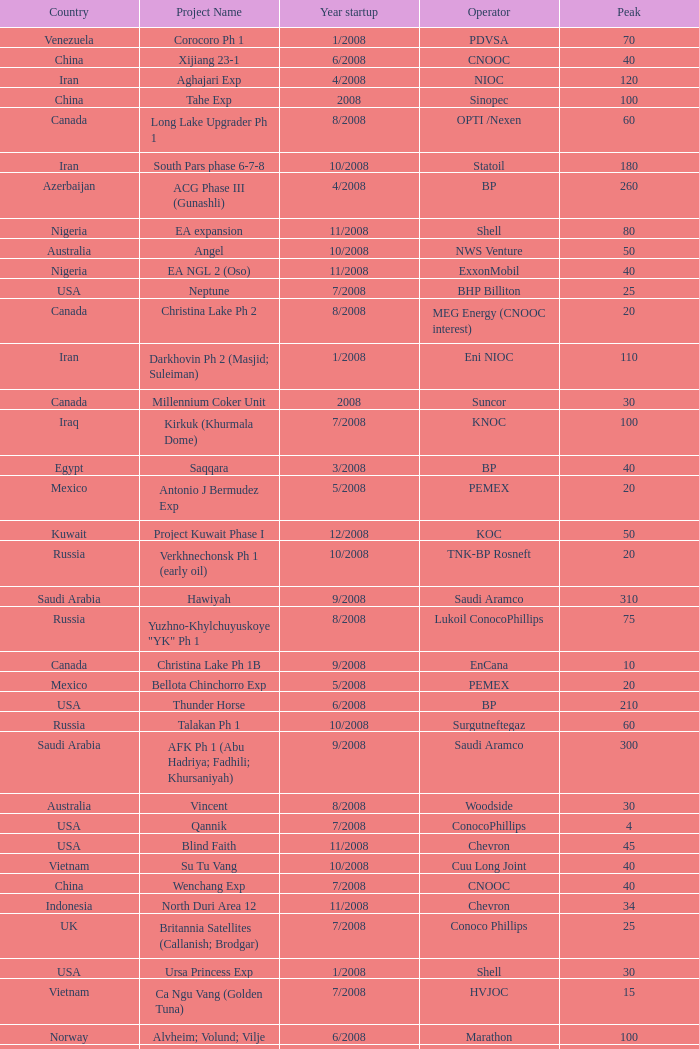Give me the full table as a dictionary. {'header': ['Country', 'Project Name', 'Year startup', 'Operator', 'Peak'], 'rows': [['Venezuela', 'Corocoro Ph 1', '1/2008', 'PDVSA', '70'], ['China', 'Xijiang 23-1', '6/2008', 'CNOOC', '40'], ['Iran', 'Aghajari Exp', '4/2008', 'NIOC', '120'], ['China', 'Tahe Exp', '2008', 'Sinopec', '100'], ['Canada', 'Long Lake Upgrader Ph 1', '8/2008', 'OPTI /Nexen', '60'], ['Iran', 'South Pars phase 6-7-8', '10/2008', 'Statoil', '180'], ['Azerbaijan', 'ACG Phase III (Gunashli)', '4/2008', 'BP', '260'], ['Nigeria', 'EA expansion', '11/2008', 'Shell', '80'], ['Australia', 'Angel', '10/2008', 'NWS Venture', '50'], ['Nigeria', 'EA NGL 2 (Oso)', '11/2008', 'ExxonMobil', '40'], ['USA', 'Neptune', '7/2008', 'BHP Billiton', '25'], ['Canada', 'Christina Lake Ph 2', '8/2008', 'MEG Energy (CNOOC interest)', '20'], ['Iran', 'Darkhovin Ph 2 (Masjid; Suleiman)', '1/2008', 'Eni NIOC', '110'], ['Canada', 'Millennium Coker Unit', '2008', 'Suncor', '30'], ['Iraq', 'Kirkuk (Khurmala Dome)', '7/2008', 'KNOC', '100'], ['Egypt', 'Saqqara', '3/2008', 'BP', '40'], ['Mexico', 'Antonio J Bermudez Exp', '5/2008', 'PEMEX', '20'], ['Kuwait', 'Project Kuwait Phase I', '12/2008', 'KOC', '50'], ['Russia', 'Verkhnechonsk Ph 1 (early oil)', '10/2008', 'TNK-BP Rosneft', '20'], ['Saudi Arabia', 'Hawiyah', '9/2008', 'Saudi Aramco', '310'], ['Russia', 'Yuzhno-Khylchuyuskoye "YK" Ph 1', '8/2008', 'Lukoil ConocoPhillips', '75'], ['Canada', 'Christina Lake Ph 1B', '9/2008', 'EnCana', '10'], ['Mexico', 'Bellota Chinchorro Exp', '5/2008', 'PEMEX', '20'], ['USA', 'Thunder Horse', '6/2008', 'BP', '210'], ['Russia', 'Talakan Ph 1', '10/2008', 'Surgutneftegaz', '60'], ['Saudi Arabia', 'AFK Ph 1 (Abu Hadriya; Fadhili; Khursaniyah)', '9/2008', 'Saudi Aramco', '300'], ['Australia', 'Vincent', '8/2008', 'Woodside', '30'], ['USA', 'Qannik', '7/2008', 'ConocoPhillips', '4'], ['USA', 'Blind Faith', '11/2008', 'Chevron', '45'], ['Vietnam', 'Su Tu Vang', '10/2008', 'Cuu Long Joint', '40'], ['China', 'Wenchang Exp', '7/2008', 'CNOOC', '40'], ['Indonesia', 'North Duri Area 12', '11/2008', 'Chevron', '34'], ['UK', 'Britannia Satellites (Callanish; Brodgar)', '7/2008', 'Conoco Phillips', '25'], ['USA', 'Ursa Princess Exp', '1/2008', 'Shell', '30'], ['Vietnam', 'Ca Ngu Vang (Golden Tuna)', '7/2008', 'HVJOC', '15'], ['Norway', 'Alvheim; Volund; Vilje', '6/2008', 'Marathon', '100'], ['Iran', 'Azadegan Phase I (south)', '2/2008', 'NIOC', '160'], ['Kazakhstan', 'Komsomolskoe', '5/2008', 'Petrom', '10'], ['Nigeria', 'Agbami', '7/2008', 'Chevron', '230'], ['Kazakhstan', 'Dunga', '3/2008', 'Maersk', '150'], ['Mexico', 'Ixtal Manik', '2008', 'PEMEX', '55'], ['Angola', 'Block 15 Kizomba C (Saxi; Batuque)', '7/2008', 'ExxonMobil', '100'], ['Thailand', 'Bualuang', '8/2008', 'Salamander', '10'], ['Angola', 'Block 15 Kizomba C (Mondo)', '1/2008', 'ExxonMobil', '100'], ['Canada', 'Jackfish Ph 1', '3/2008', 'Devon Energy', '30'], ['Brazil', 'Cachalote Pilot (Baleia Franca)', '12/2008', 'Petrobras', '25'], ['Norway', 'Volve', '2/2008', 'StatoilHydro', '35'], ['Philippines', 'Galoc', '10/2008', 'GPC', '15'], ['Brazil', 'Marlim Leste P-53', '11/2008', 'Petrobras', '180'], ['Iraq', 'Tawke', '7/2008', 'DNO', '50'], ['Mexico', '( Chicontepec ) Exp 1', '2008', 'PEMEX', '200'], ['Non-OPEC', 'Non-OPEC', 'Non-OPEC', 'Non-OPEC', 'Non-OPEC'], ['Vietnam', 'Song Doc', '12/2008', 'Talisman', '10'], ['Mexico', 'Jujo Tecominoacan Exp', '2008', 'PEMEX', '15'], ['China', 'Erdos CTL Ph 1', '10/2008', 'Shenhua', '20'], ['Canada', 'Horizon Oil Sands Project (Phase I)', '12/2008', 'CNRL', '110'], ['Oman', 'Mukhaizna EOR Ph 1', '2008', 'Occidental', '40'], ['India', 'MA field (KG-D6)', '9/2008', 'Reliance', '40'], ['Congo', 'Moho Bilondo', '4/2008', 'Total', '90'], ['Brazil', 'Badejo-Siri (FPSO Cidade de Rio das Ostras)', '4/2008', 'Petrobras', '15'], ['USA', 'Oooguruk', '6/2008', 'Pioneer', '15'], ['OPEC', 'OPEC', 'OPEC', 'OPEC', 'OPEC']]} What is the Project Name with a Country that is opec? OPEC. 